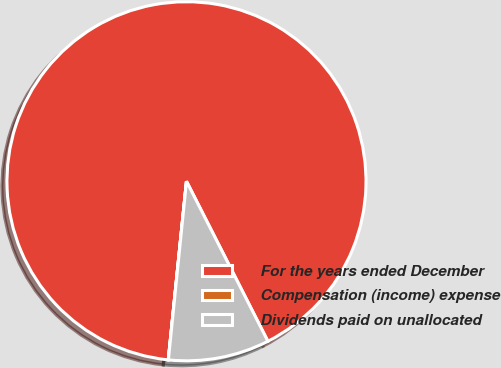<chart> <loc_0><loc_0><loc_500><loc_500><pie_chart><fcel>For the years ended December<fcel>Compensation (income) expense<fcel>Dividends paid on unallocated<nl><fcel>90.89%<fcel>0.01%<fcel>9.1%<nl></chart> 